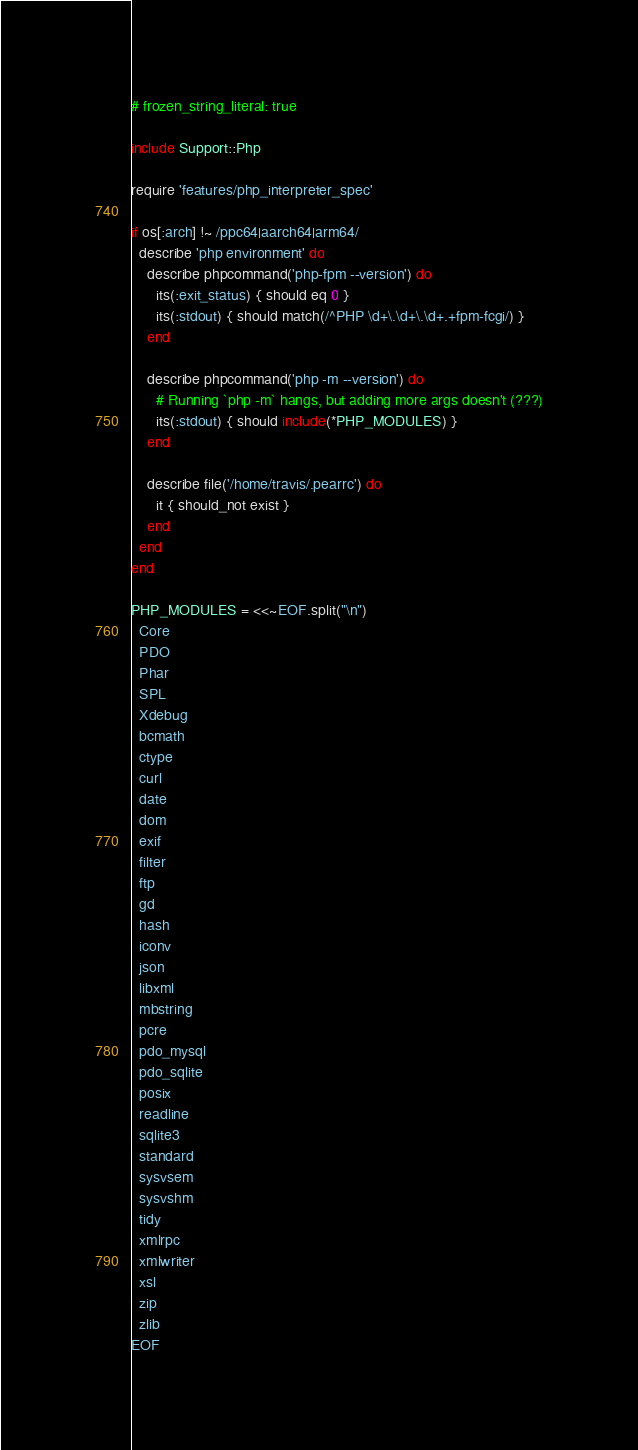<code> <loc_0><loc_0><loc_500><loc_500><_Ruby_># frozen_string_literal: true

include Support::Php

require 'features/php_interpreter_spec'

if os[:arch] !~ /ppc64|aarch64|arm64/
  describe 'php environment' do
    describe phpcommand('php-fpm --version') do
      its(:exit_status) { should eq 0 }
      its(:stdout) { should match(/^PHP \d+\.\d+\.\d+.+fpm-fcgi/) }
    end

    describe phpcommand('php -m --version') do
      # Running `php -m` hangs, but adding more args doesn't (???)
      its(:stdout) { should include(*PHP_MODULES) }
    end

    describe file('/home/travis/.pearrc') do
      it { should_not exist }
    end
  end
end

PHP_MODULES = <<~EOF.split("\n")
  Core
  PDO
  Phar
  SPL
  Xdebug
  bcmath
  ctype
  curl
  date
  dom
  exif
  filter
  ftp
  gd
  hash
  iconv
  json
  libxml
  mbstring
  pcre
  pdo_mysql
  pdo_sqlite
  posix
  readline
  sqlite3
  standard
  sysvsem
  sysvshm
  tidy
  xmlrpc
  xmlwriter
  xsl
  zip
  zlib
EOF
</code> 